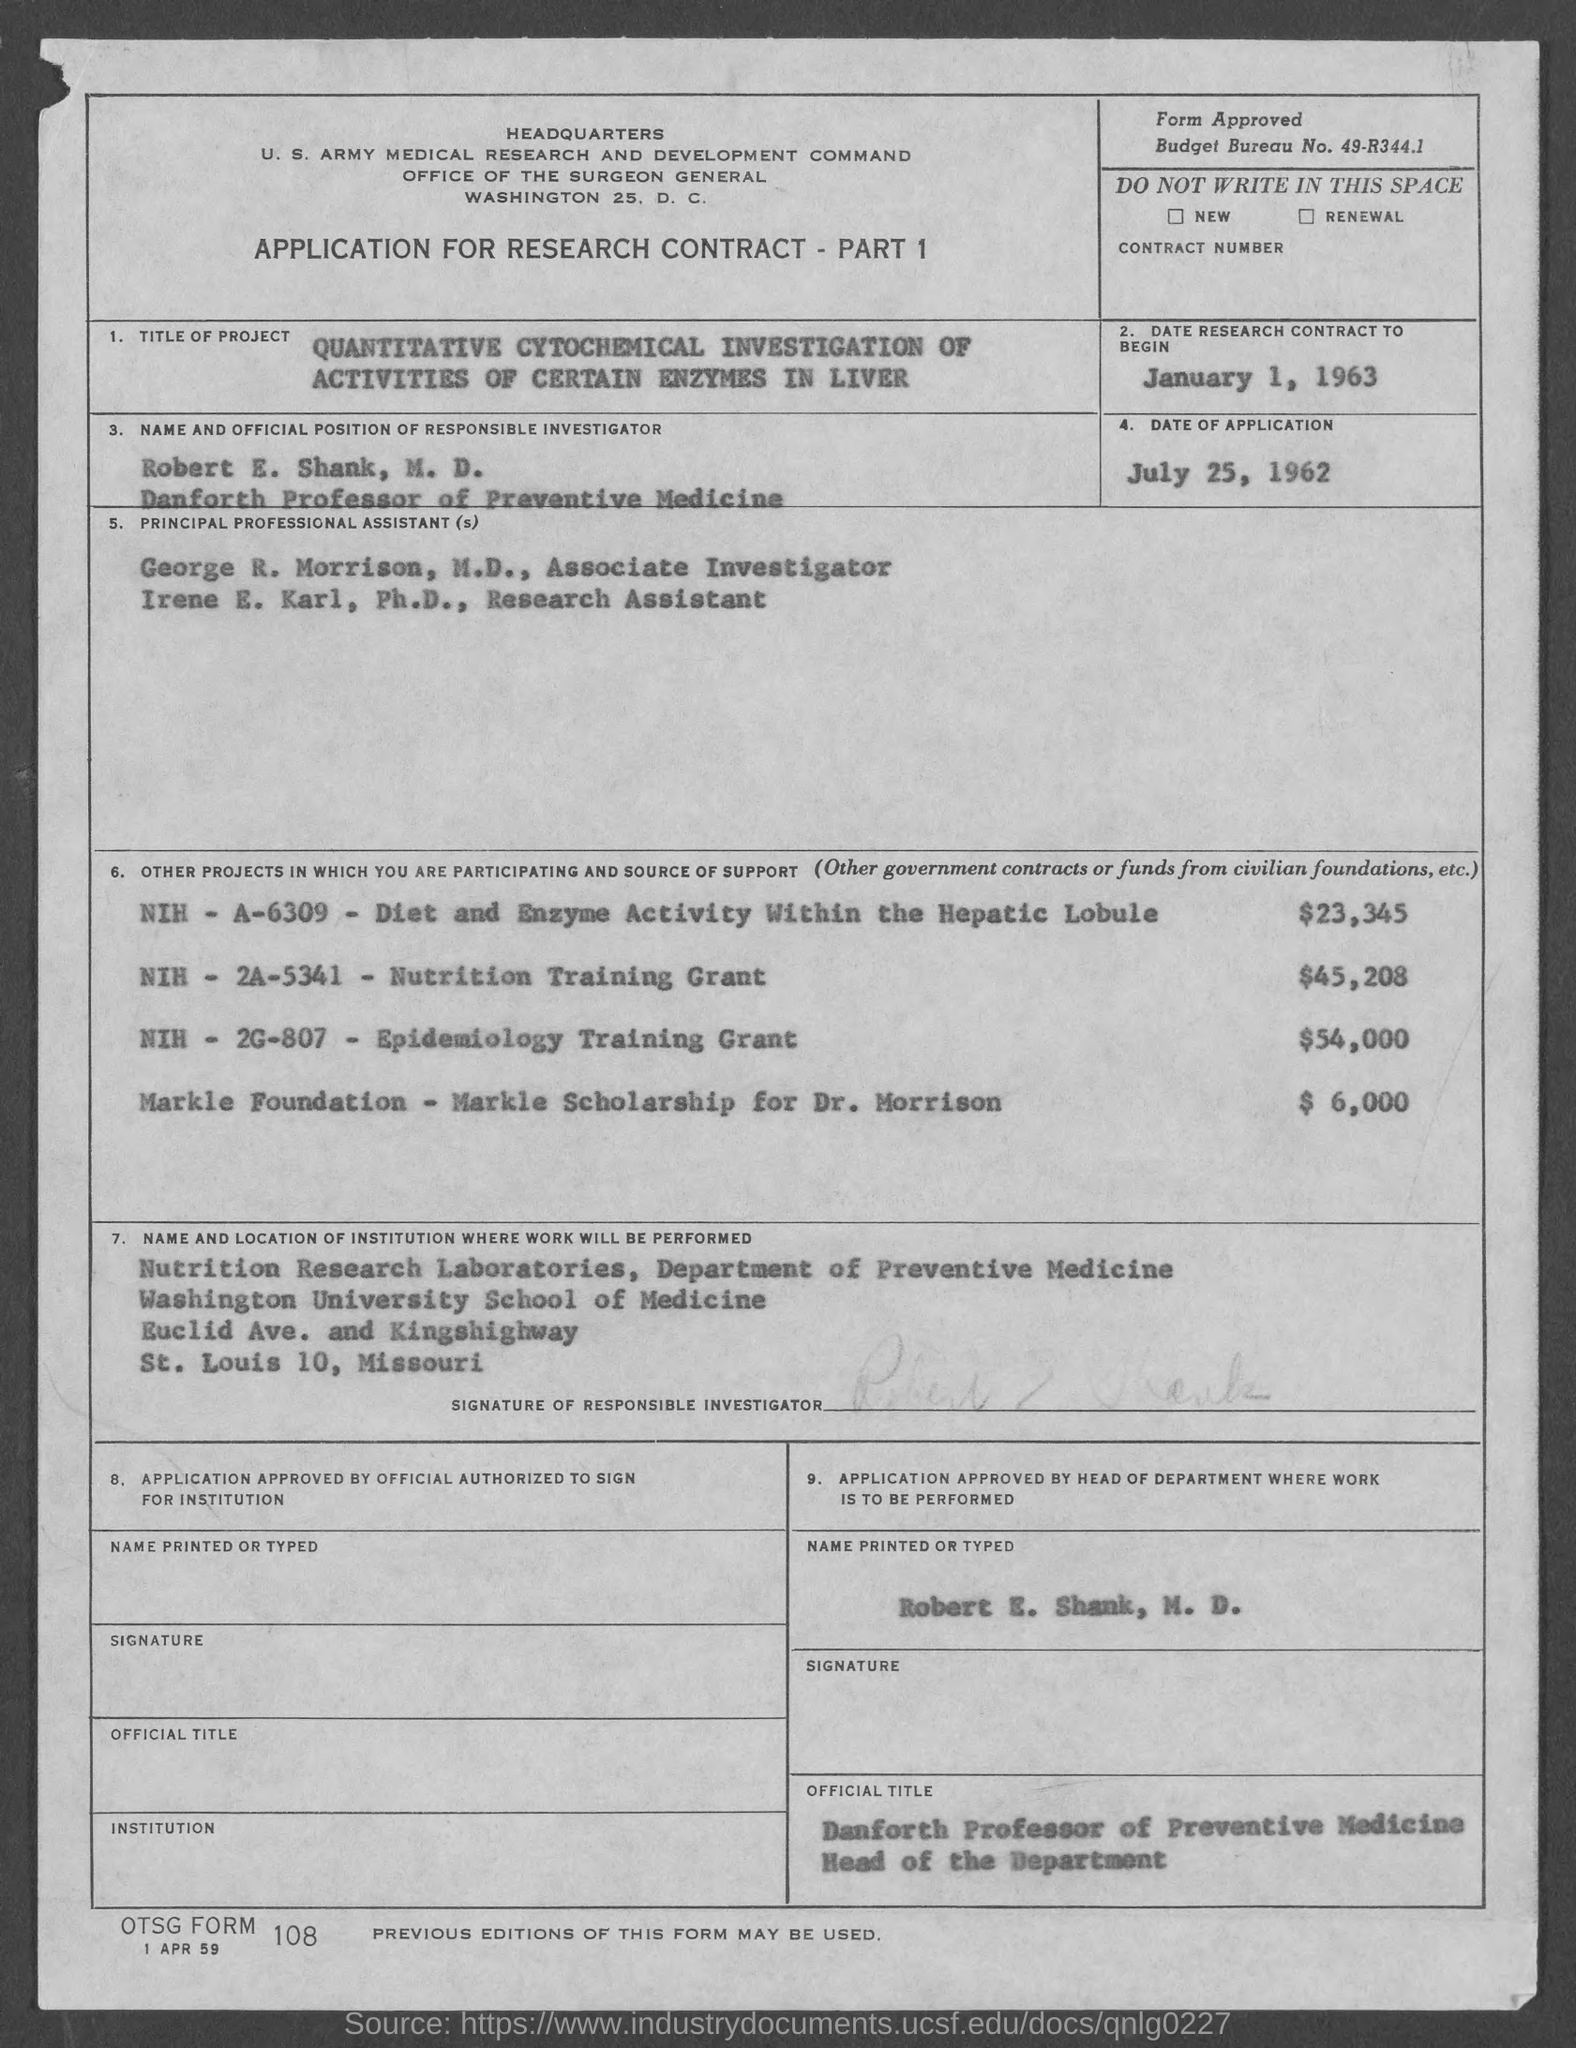What is the date research contract to begin ?
Offer a terse response. January 1, 1963. What is the date of application?
Make the answer very short. July 25, 1962. What is the budget bureau no.?
Ensure brevity in your answer.  49-R344.1. What is the position of robert e. shank, m.d.?
Provide a succinct answer. Danforth Professor of Preventive Medicine. What is the position of george r. morrison, m.d.?
Keep it short and to the point. Associate Investigator. What is the position of irene e. karl, ph.d.?
Give a very brief answer. Research assistant. 